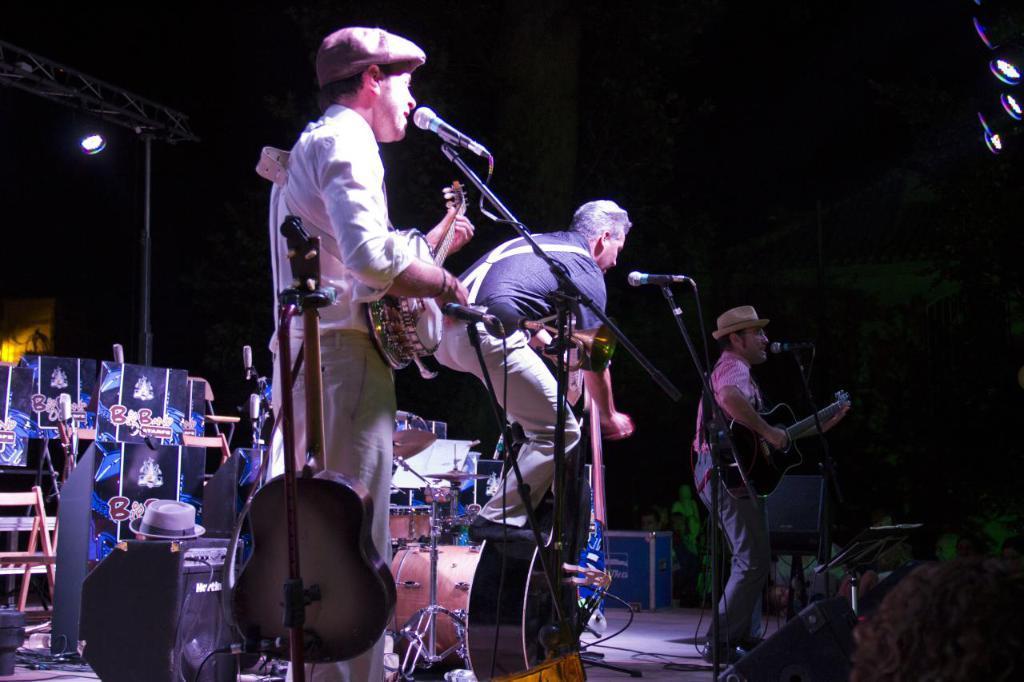Please provide a concise description of this image. On the stage there are three man performing something. A man on the right side he is playing guitar and i think he is singing ,he wear a hat ,trouser. A man in the middle he wear a shirt and trouser. A man on the left he is singing and playing a musical instrument he wear a cap. In the back ground there are many musical instruments , that , some text , light ,pole. I think this is a stage performance. 